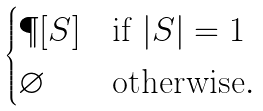Convert formula to latex. <formula><loc_0><loc_0><loc_500><loc_500>\begin{cases} \P [ S ] & \text {if } | S | = 1 \\ \varnothing & \text {otherwise} . \end{cases}</formula> 